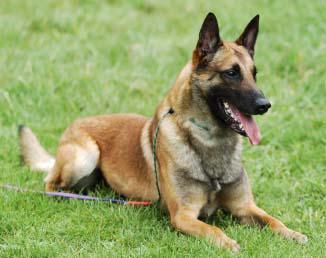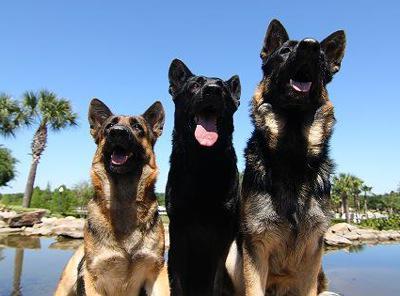The first image is the image on the left, the second image is the image on the right. Analyze the images presented: Is the assertion "There are at most four dogs." valid? Answer yes or no. Yes. The first image is the image on the left, the second image is the image on the right. Considering the images on both sides, is "The left image includes three german shepherds with tongues out, in reclining poses with front paws extended and flat on the ground." valid? Answer yes or no. No. 